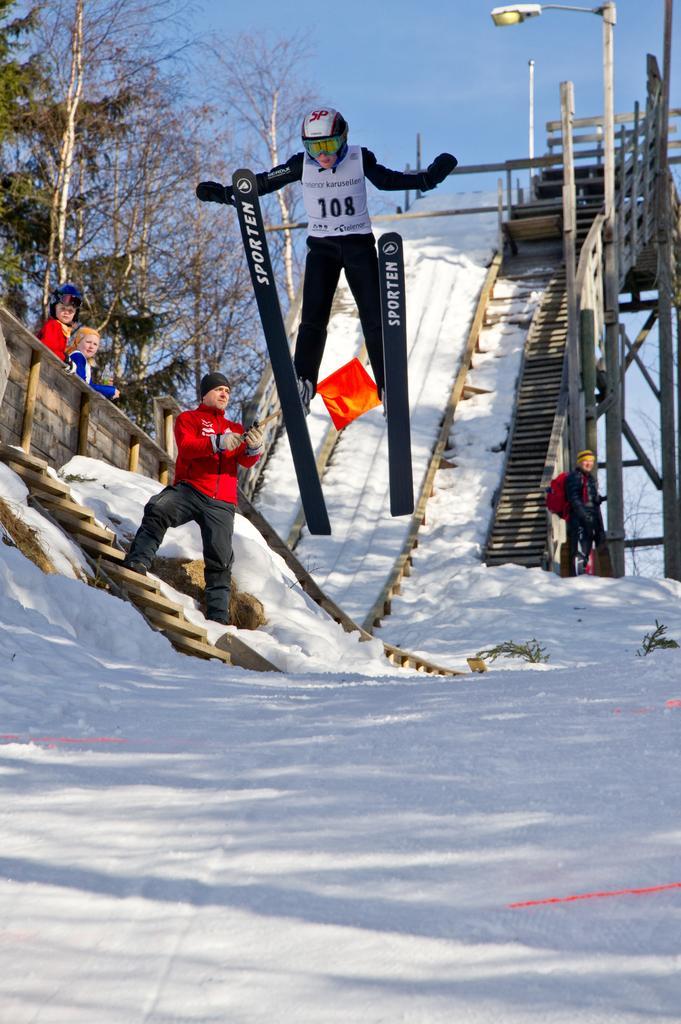Please provide a concise description of this image. In this picture I can observe a person on the skiing boards. He is wearing helmet on his head. I can observe some snow on the land. In the background there are trees and sky. 